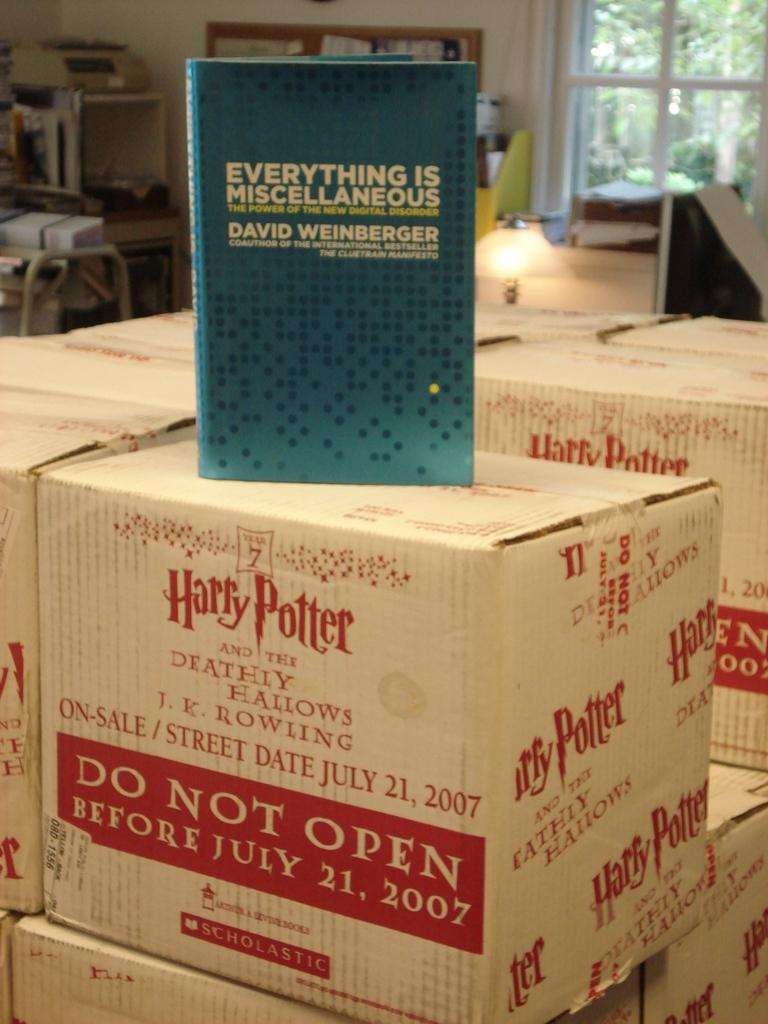<image>
Relay a brief, clear account of the picture shown. A box of Harry Potter books, with the book "Everything is Miscellaneous" on top 